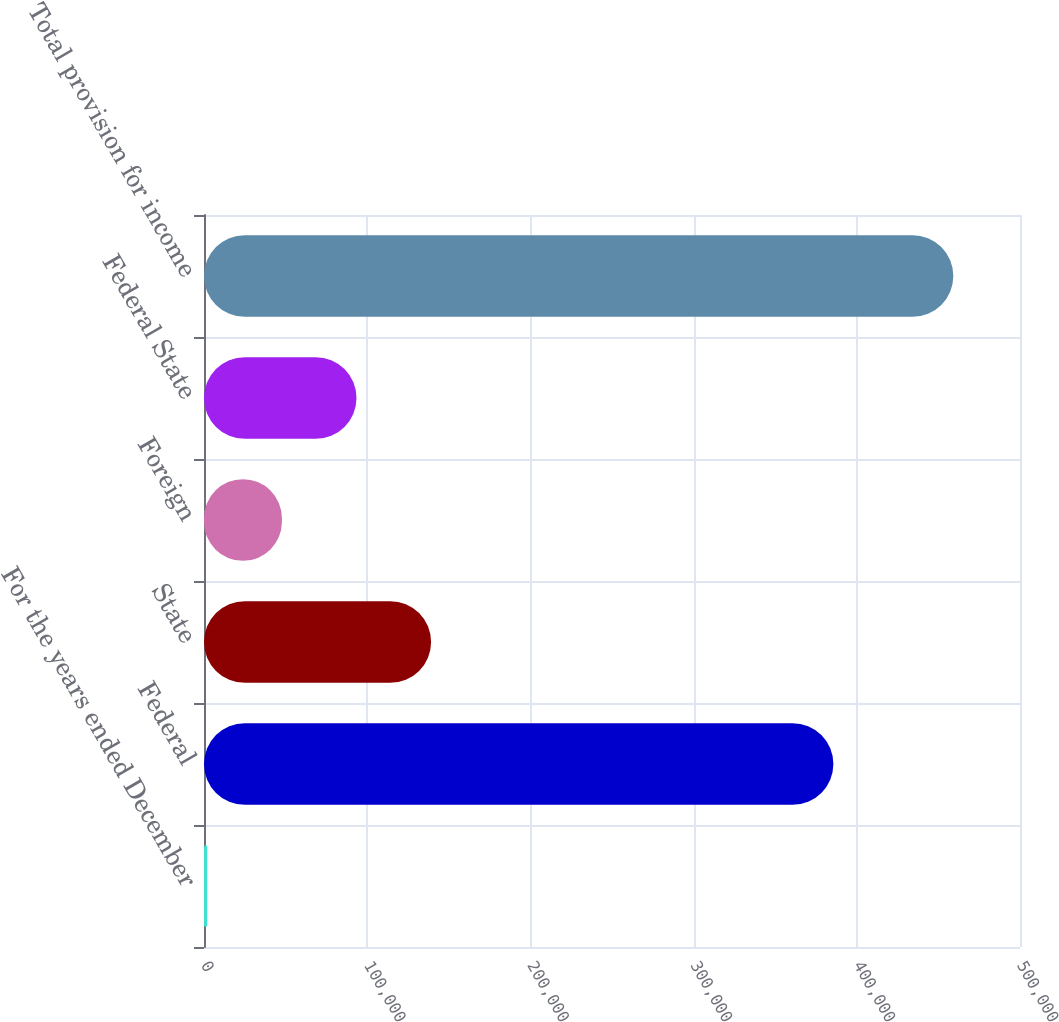Convert chart to OTSL. <chart><loc_0><loc_0><loc_500><loc_500><bar_chart><fcel>For the years ended December<fcel>Federal<fcel>State<fcel>Foreign<fcel>Federal State<fcel>Total provision for income<nl><fcel>2014<fcel>385642<fcel>139149<fcel>47725.7<fcel>93437.4<fcel>459131<nl></chart> 